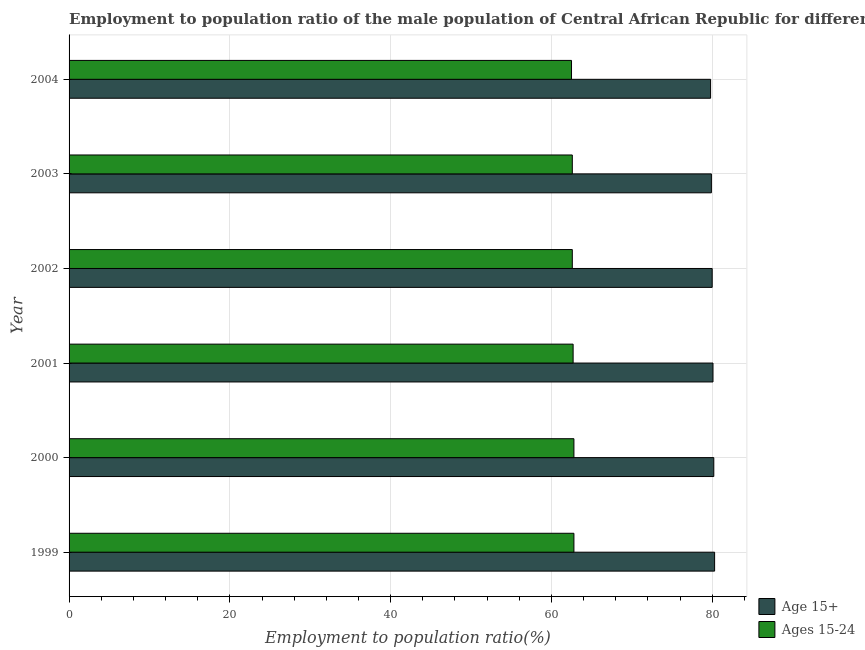Are the number of bars on each tick of the Y-axis equal?
Give a very brief answer. Yes. How many bars are there on the 4th tick from the bottom?
Your response must be concise. 2. What is the label of the 5th group of bars from the top?
Provide a succinct answer. 2000. In how many cases, is the number of bars for a given year not equal to the number of legend labels?
Your answer should be very brief. 0. What is the employment to population ratio(age 15-24) in 2000?
Keep it short and to the point. 62.8. Across all years, what is the maximum employment to population ratio(age 15-24)?
Provide a short and direct response. 62.8. Across all years, what is the minimum employment to population ratio(age 15+)?
Give a very brief answer. 79.8. What is the total employment to population ratio(age 15+) in the graph?
Provide a short and direct response. 480.3. What is the difference between the employment to population ratio(age 15+) in 2002 and the employment to population ratio(age 15-24) in 1999?
Offer a terse response. 17.2. What is the average employment to population ratio(age 15+) per year?
Give a very brief answer. 80.05. In the year 2003, what is the difference between the employment to population ratio(age 15-24) and employment to population ratio(age 15+)?
Keep it short and to the point. -17.3. Is the difference between the employment to population ratio(age 15+) in 1999 and 2003 greater than the difference between the employment to population ratio(age 15-24) in 1999 and 2003?
Provide a short and direct response. Yes. What is the difference between the highest and the lowest employment to population ratio(age 15-24)?
Give a very brief answer. 0.3. What does the 1st bar from the top in 2002 represents?
Offer a very short reply. Ages 15-24. What does the 1st bar from the bottom in 2001 represents?
Offer a terse response. Age 15+. How many bars are there?
Provide a succinct answer. 12. Are the values on the major ticks of X-axis written in scientific E-notation?
Your response must be concise. No. How many legend labels are there?
Ensure brevity in your answer.  2. What is the title of the graph?
Keep it short and to the point. Employment to population ratio of the male population of Central African Republic for different age-groups. What is the label or title of the X-axis?
Give a very brief answer. Employment to population ratio(%). What is the label or title of the Y-axis?
Ensure brevity in your answer.  Year. What is the Employment to population ratio(%) of Age 15+ in 1999?
Offer a very short reply. 80.3. What is the Employment to population ratio(%) in Ages 15-24 in 1999?
Offer a terse response. 62.8. What is the Employment to population ratio(%) in Age 15+ in 2000?
Ensure brevity in your answer.  80.2. What is the Employment to population ratio(%) in Ages 15-24 in 2000?
Keep it short and to the point. 62.8. What is the Employment to population ratio(%) in Age 15+ in 2001?
Give a very brief answer. 80.1. What is the Employment to population ratio(%) in Ages 15-24 in 2001?
Your response must be concise. 62.7. What is the Employment to population ratio(%) in Age 15+ in 2002?
Your answer should be compact. 80. What is the Employment to population ratio(%) in Ages 15-24 in 2002?
Ensure brevity in your answer.  62.6. What is the Employment to population ratio(%) in Age 15+ in 2003?
Make the answer very short. 79.9. What is the Employment to population ratio(%) in Ages 15-24 in 2003?
Provide a short and direct response. 62.6. What is the Employment to population ratio(%) of Age 15+ in 2004?
Your answer should be compact. 79.8. What is the Employment to population ratio(%) of Ages 15-24 in 2004?
Keep it short and to the point. 62.5. Across all years, what is the maximum Employment to population ratio(%) in Age 15+?
Provide a short and direct response. 80.3. Across all years, what is the maximum Employment to population ratio(%) in Ages 15-24?
Provide a short and direct response. 62.8. Across all years, what is the minimum Employment to population ratio(%) of Age 15+?
Your response must be concise. 79.8. Across all years, what is the minimum Employment to population ratio(%) in Ages 15-24?
Provide a succinct answer. 62.5. What is the total Employment to population ratio(%) of Age 15+ in the graph?
Your response must be concise. 480.3. What is the total Employment to population ratio(%) in Ages 15-24 in the graph?
Offer a very short reply. 376. What is the difference between the Employment to population ratio(%) of Age 15+ in 1999 and that in 2001?
Offer a very short reply. 0.2. What is the difference between the Employment to population ratio(%) in Age 15+ in 1999 and that in 2002?
Provide a short and direct response. 0.3. What is the difference between the Employment to population ratio(%) in Age 15+ in 1999 and that in 2003?
Ensure brevity in your answer.  0.4. What is the difference between the Employment to population ratio(%) of Ages 15-24 in 1999 and that in 2003?
Ensure brevity in your answer.  0.2. What is the difference between the Employment to population ratio(%) of Age 15+ in 1999 and that in 2004?
Offer a very short reply. 0.5. What is the difference between the Employment to population ratio(%) in Ages 15-24 in 1999 and that in 2004?
Offer a very short reply. 0.3. What is the difference between the Employment to population ratio(%) in Ages 15-24 in 2000 and that in 2001?
Provide a short and direct response. 0.1. What is the difference between the Employment to population ratio(%) of Ages 15-24 in 2000 and that in 2002?
Give a very brief answer. 0.2. What is the difference between the Employment to population ratio(%) of Age 15+ in 2000 and that in 2003?
Offer a very short reply. 0.3. What is the difference between the Employment to population ratio(%) of Age 15+ in 2000 and that in 2004?
Your answer should be very brief. 0.4. What is the difference between the Employment to population ratio(%) in Age 15+ in 2001 and that in 2003?
Provide a succinct answer. 0.2. What is the difference between the Employment to population ratio(%) of Ages 15-24 in 2001 and that in 2003?
Make the answer very short. 0.1. What is the difference between the Employment to population ratio(%) of Age 15+ in 2001 and that in 2004?
Offer a very short reply. 0.3. What is the difference between the Employment to population ratio(%) in Ages 15-24 in 2001 and that in 2004?
Make the answer very short. 0.2. What is the difference between the Employment to population ratio(%) in Ages 15-24 in 2002 and that in 2003?
Your response must be concise. 0. What is the difference between the Employment to population ratio(%) of Ages 15-24 in 2002 and that in 2004?
Ensure brevity in your answer.  0.1. What is the difference between the Employment to population ratio(%) of Ages 15-24 in 2003 and that in 2004?
Provide a short and direct response. 0.1. What is the difference between the Employment to population ratio(%) of Age 15+ in 1999 and the Employment to population ratio(%) of Ages 15-24 in 2001?
Keep it short and to the point. 17.6. What is the difference between the Employment to population ratio(%) of Age 15+ in 1999 and the Employment to population ratio(%) of Ages 15-24 in 2003?
Provide a succinct answer. 17.7. What is the difference between the Employment to population ratio(%) of Age 15+ in 2000 and the Employment to population ratio(%) of Ages 15-24 in 2003?
Offer a terse response. 17.6. What is the difference between the Employment to population ratio(%) of Age 15+ in 2001 and the Employment to population ratio(%) of Ages 15-24 in 2002?
Your answer should be very brief. 17.5. What is the difference between the Employment to population ratio(%) of Age 15+ in 2001 and the Employment to population ratio(%) of Ages 15-24 in 2004?
Offer a terse response. 17.6. What is the difference between the Employment to population ratio(%) of Age 15+ in 2002 and the Employment to population ratio(%) of Ages 15-24 in 2003?
Offer a very short reply. 17.4. What is the difference between the Employment to population ratio(%) of Age 15+ in 2002 and the Employment to population ratio(%) of Ages 15-24 in 2004?
Offer a very short reply. 17.5. What is the difference between the Employment to population ratio(%) of Age 15+ in 2003 and the Employment to population ratio(%) of Ages 15-24 in 2004?
Your answer should be very brief. 17.4. What is the average Employment to population ratio(%) in Age 15+ per year?
Give a very brief answer. 80.05. What is the average Employment to population ratio(%) in Ages 15-24 per year?
Offer a very short reply. 62.67. In the year 2004, what is the difference between the Employment to population ratio(%) in Age 15+ and Employment to population ratio(%) in Ages 15-24?
Give a very brief answer. 17.3. What is the ratio of the Employment to population ratio(%) in Ages 15-24 in 1999 to that in 2001?
Your response must be concise. 1. What is the ratio of the Employment to population ratio(%) in Age 15+ in 1999 to that in 2003?
Your answer should be very brief. 1. What is the ratio of the Employment to population ratio(%) in Age 15+ in 1999 to that in 2004?
Give a very brief answer. 1.01. What is the ratio of the Employment to population ratio(%) of Ages 15-24 in 1999 to that in 2004?
Keep it short and to the point. 1. What is the ratio of the Employment to population ratio(%) in Ages 15-24 in 2000 to that in 2001?
Keep it short and to the point. 1. What is the ratio of the Employment to population ratio(%) of Age 15+ in 2000 to that in 2002?
Ensure brevity in your answer.  1. What is the ratio of the Employment to population ratio(%) in Ages 15-24 in 2000 to that in 2002?
Your answer should be very brief. 1. What is the ratio of the Employment to population ratio(%) in Ages 15-24 in 2000 to that in 2003?
Give a very brief answer. 1. What is the ratio of the Employment to population ratio(%) in Age 15+ in 2000 to that in 2004?
Offer a terse response. 1. What is the ratio of the Employment to population ratio(%) in Ages 15-24 in 2001 to that in 2002?
Ensure brevity in your answer.  1. What is the ratio of the Employment to population ratio(%) in Ages 15-24 in 2001 to that in 2003?
Provide a succinct answer. 1. What is the ratio of the Employment to population ratio(%) of Ages 15-24 in 2001 to that in 2004?
Offer a very short reply. 1. What is the ratio of the Employment to population ratio(%) in Age 15+ in 2002 to that in 2004?
Make the answer very short. 1. What is the ratio of the Employment to population ratio(%) in Ages 15-24 in 2002 to that in 2004?
Offer a terse response. 1. What is the ratio of the Employment to population ratio(%) of Age 15+ in 2003 to that in 2004?
Provide a short and direct response. 1. What is the ratio of the Employment to population ratio(%) in Ages 15-24 in 2003 to that in 2004?
Your response must be concise. 1. What is the difference between the highest and the second highest Employment to population ratio(%) in Ages 15-24?
Your answer should be very brief. 0. What is the difference between the highest and the lowest Employment to population ratio(%) in Age 15+?
Ensure brevity in your answer.  0.5. What is the difference between the highest and the lowest Employment to population ratio(%) in Ages 15-24?
Ensure brevity in your answer.  0.3. 